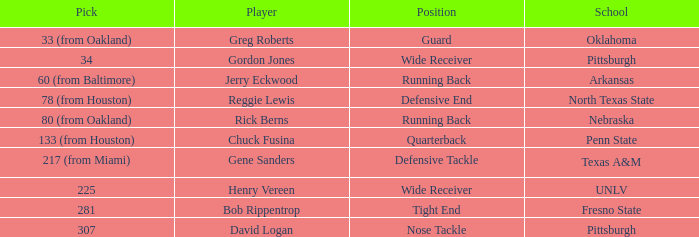Would you be able to parse every entry in this table? {'header': ['Pick', 'Player', 'Position', 'School'], 'rows': [['33 (from Oakland)', 'Greg Roberts', 'Guard', 'Oklahoma'], ['34', 'Gordon Jones', 'Wide Receiver', 'Pittsburgh'], ['60 (from Baltimore)', 'Jerry Eckwood', 'Running Back', 'Arkansas'], ['78 (from Houston)', 'Reggie Lewis', 'Defensive End', 'North Texas State'], ['80 (from Oakland)', 'Rick Berns', 'Running Back', 'Nebraska'], ['133 (from Houston)', 'Chuck Fusina', 'Quarterback', 'Penn State'], ['217 (from Miami)', 'Gene Sanders', 'Defensive Tackle', 'Texas A&M'], ['225', 'Henry Vereen', 'Wide Receiver', 'UNLV'], ['281', 'Bob Rippentrop', 'Tight End', 'Fresno State'], ['307', 'David Logan', 'Nose Tackle', 'Pittsburgh']]} What round was the nose tackle drafted? 12.0. 